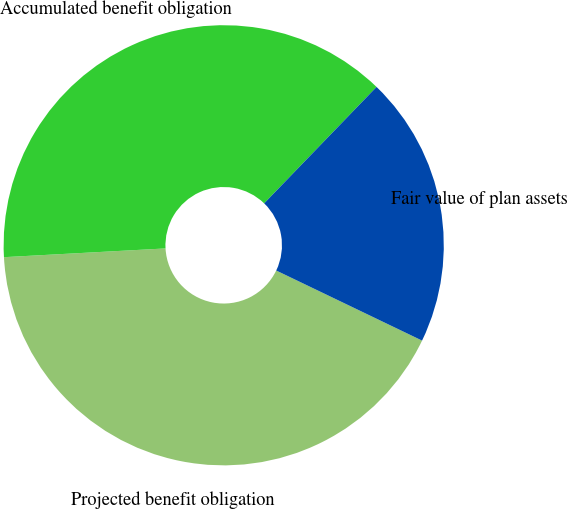<chart> <loc_0><loc_0><loc_500><loc_500><pie_chart><fcel>Projected benefit obligation<fcel>Accumulated benefit obligation<fcel>Fair value of plan assets<nl><fcel>42.01%<fcel>38.08%<fcel>19.91%<nl></chart> 